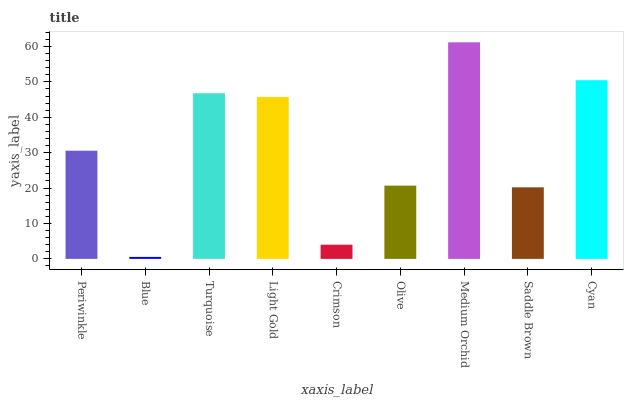Is Blue the minimum?
Answer yes or no. Yes. Is Medium Orchid the maximum?
Answer yes or no. Yes. Is Turquoise the minimum?
Answer yes or no. No. Is Turquoise the maximum?
Answer yes or no. No. Is Turquoise greater than Blue?
Answer yes or no. Yes. Is Blue less than Turquoise?
Answer yes or no. Yes. Is Blue greater than Turquoise?
Answer yes or no. No. Is Turquoise less than Blue?
Answer yes or no. No. Is Periwinkle the high median?
Answer yes or no. Yes. Is Periwinkle the low median?
Answer yes or no. Yes. Is Crimson the high median?
Answer yes or no. No. Is Turquoise the low median?
Answer yes or no. No. 